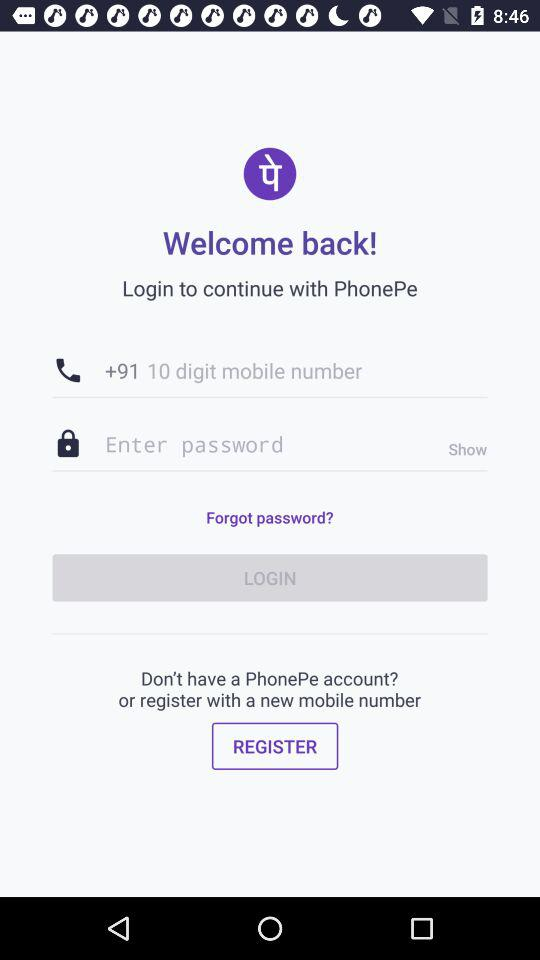What is the application name? The application name is "PhonePe". 